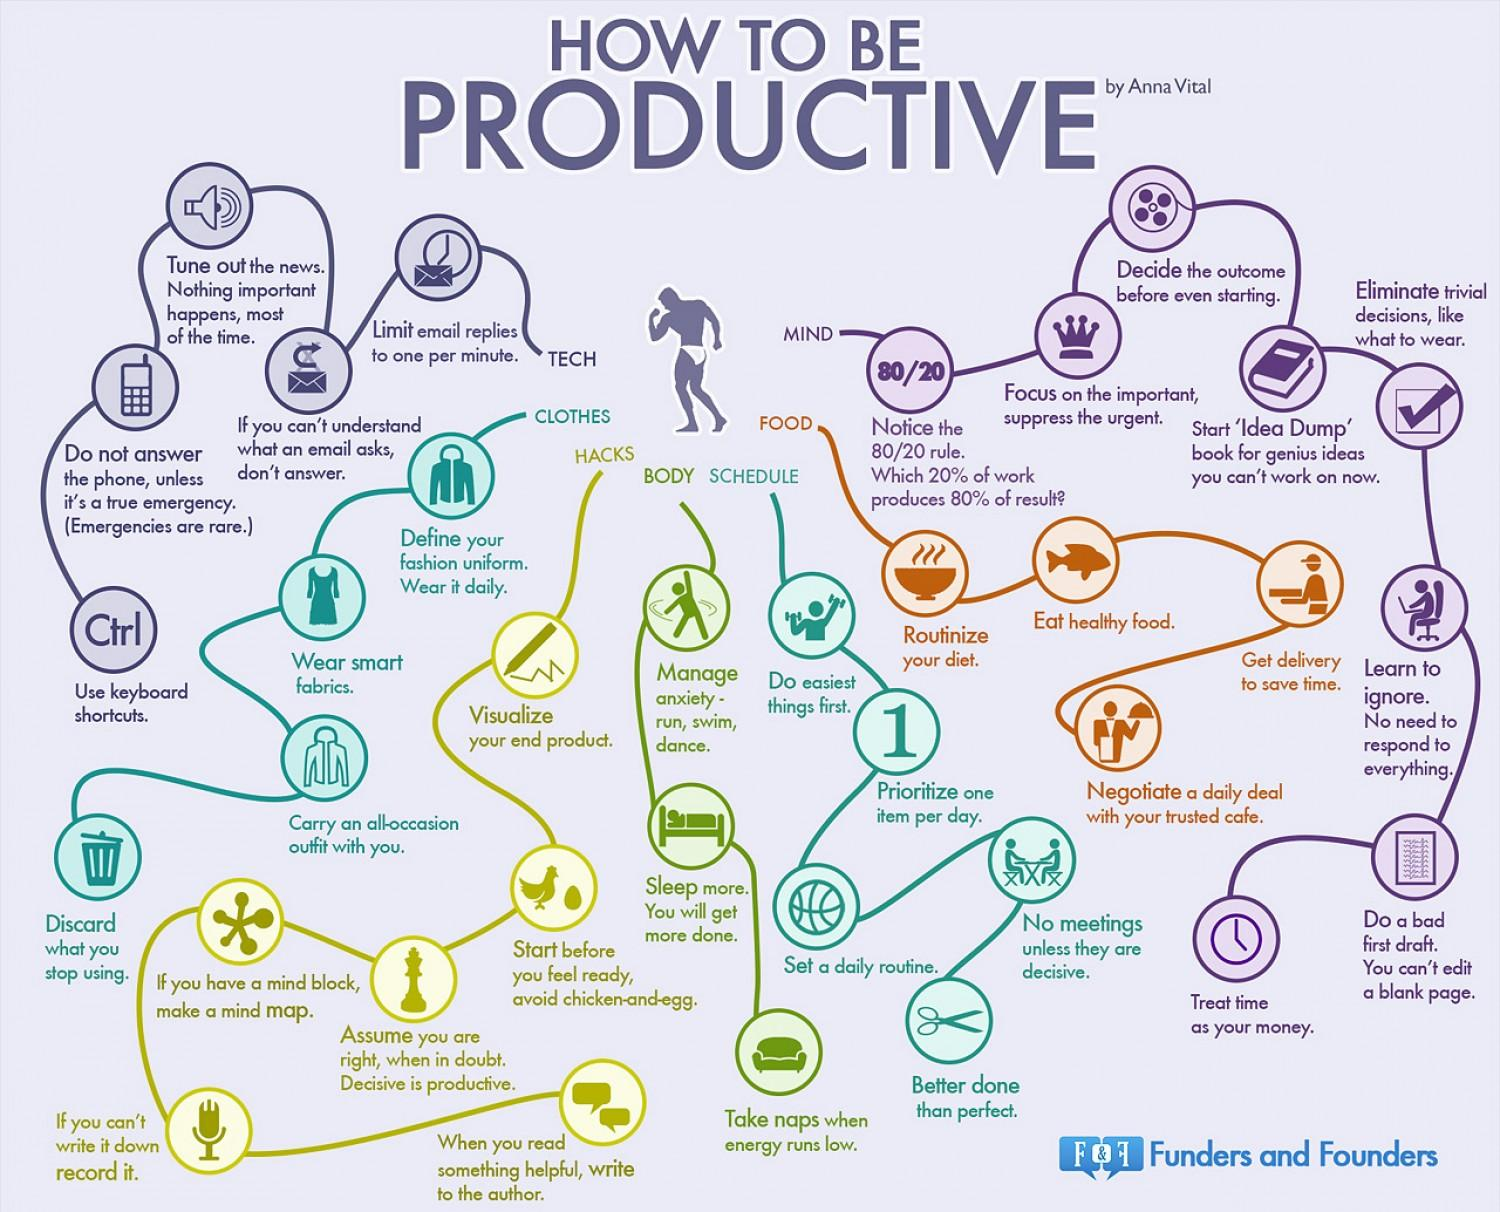Identify some key points in this picture. Food can be delivered to save time, making it a valuable item to consider when seeking to save time. Dance is the third physical activity mentioned that helps to manage anxiety. I recommend discarding the clothes item if I stop using it. Four tips are mentioned under the subheading FOOD. 